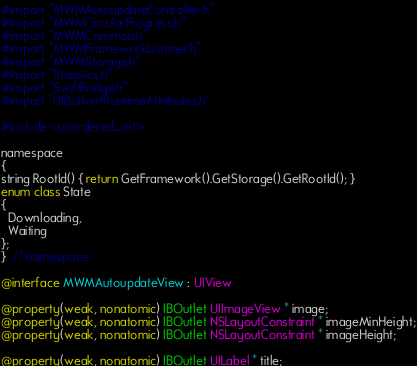Convert code to text. <code><loc_0><loc_0><loc_500><loc_500><_ObjectiveC_>#import "MWMAutoupdateController.h"
#import "MWMCircularProgress.h"
#import "MWMCommon.h"
#import "MWMFrameworkListener.h"
#import "MWMStorage.h"
#import "Statistics.h"
#import "SwiftBridge.h"
#import "UIButton+RuntimeAttributes.h"

#include <unordered_set>

namespace
{
string RootId() { return GetFramework().GetStorage().GetRootId(); }
enum class State
{
  Downloading,
  Waiting
};
}  // namespace

@interface MWMAutoupdateView : UIView

@property(weak, nonatomic) IBOutlet UIImageView * image;
@property(weak, nonatomic) IBOutlet NSLayoutConstraint * imageMinHeight;
@property(weak, nonatomic) IBOutlet NSLayoutConstraint * imageHeight;

@property(weak, nonatomic) IBOutlet UILabel * title;</code> 